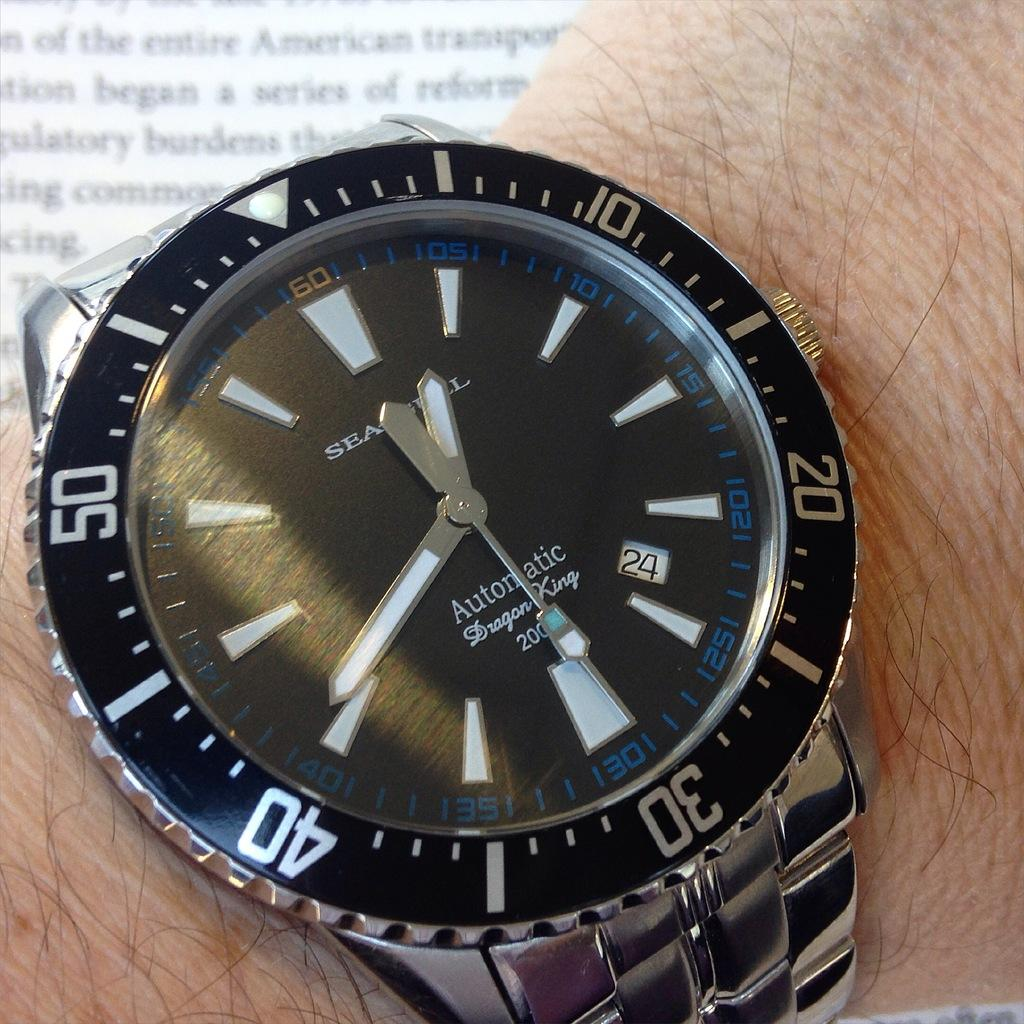<image>
Present a compact description of the photo's key features. A person is wearing a silver Dragon King watch on their wrist. 